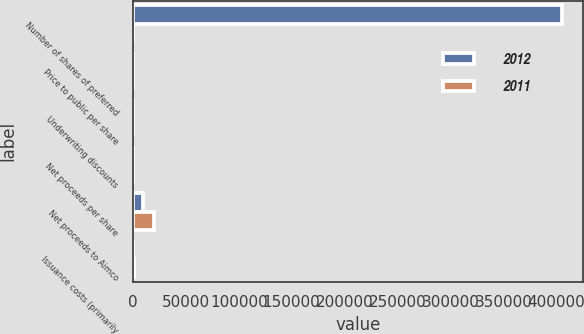Convert chart to OTSL. <chart><loc_0><loc_0><loc_500><loc_500><stacked_bar_chart><ecel><fcel>Number of shares of preferred<fcel>Price to public per share<fcel>Underwriting discounts<fcel>Net proceeds per share<fcel>Net proceeds to Aimco<fcel>Issuance costs (primarily<nl><fcel>2012<fcel>405090<fcel>24.78<fcel>0.54<fcel>24.24<fcel>9818<fcel>221<nl><fcel>2011<fcel>24.78<fcel>24.25<fcel>1.25<fcel>23<fcel>19990<fcel>1085<nl></chart> 